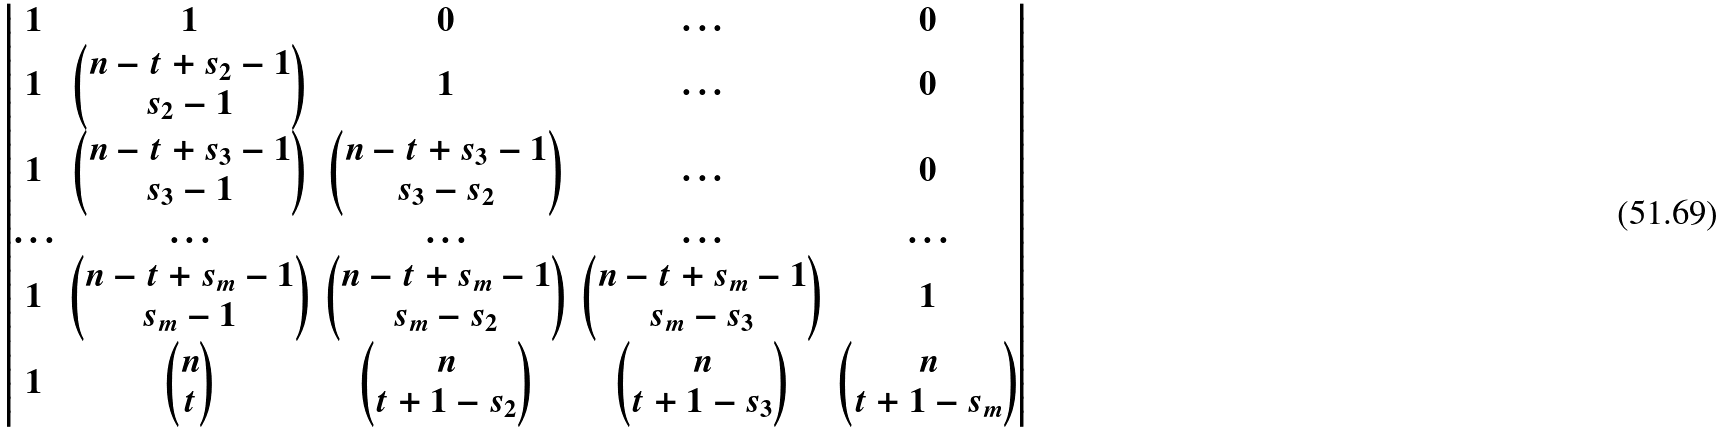<formula> <loc_0><loc_0><loc_500><loc_500>\begin{vmatrix} 1 & 1 & 0 & \hdots & 0 \\ 1 & \begin{pmatrix} n - t + s _ { 2 } - 1 \\ s _ { 2 } - 1 \end{pmatrix} & 1 & \hdots & 0 \\ 1 & \begin{pmatrix} n - t + s _ { 3 } - 1 \\ s _ { 3 } - 1 \end{pmatrix} & \begin{pmatrix} n - t + s _ { 3 } - 1 \\ s _ { 3 } - s _ { 2 } \end{pmatrix} & \hdots & 0 \\ \hdots & \hdots & \hdots & \hdots & \hdots \\ 1 & \begin{pmatrix} n - t + s _ { m } - 1 \\ s _ { m } - 1 \end{pmatrix} & \begin{pmatrix} n - t + s _ { m } - 1 \\ s _ { m } - s _ { 2 } \end{pmatrix} & \begin{pmatrix} n - t + s _ { m } - 1 \\ s _ { m } - s _ { 3 } \end{pmatrix} & 1 \\ 1 & \begin{pmatrix} n \\ t \end{pmatrix} & \begin{pmatrix} n \\ t + 1 - s _ { 2 } \end{pmatrix} & \begin{pmatrix} n \\ t + 1 - s _ { 3 } \end{pmatrix} & \begin{pmatrix} n \\ t + 1 - s _ { m } \end{pmatrix} \end{vmatrix}</formula> 